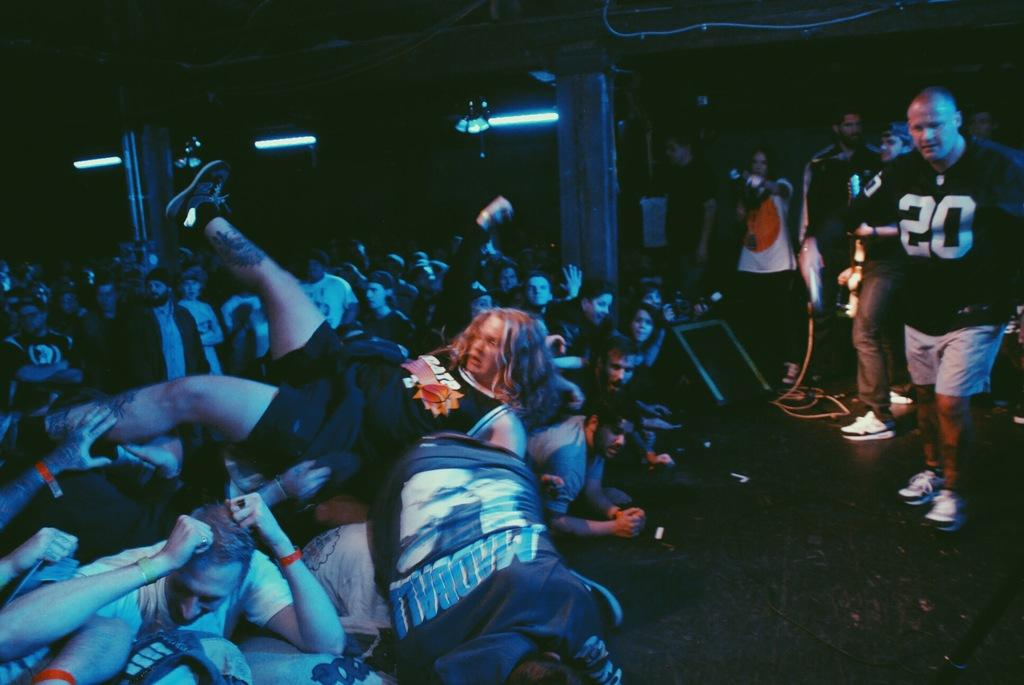<image>
Offer a succinct explanation of the picture presented. Number 20 is shown on the jersey of the man on stage. 